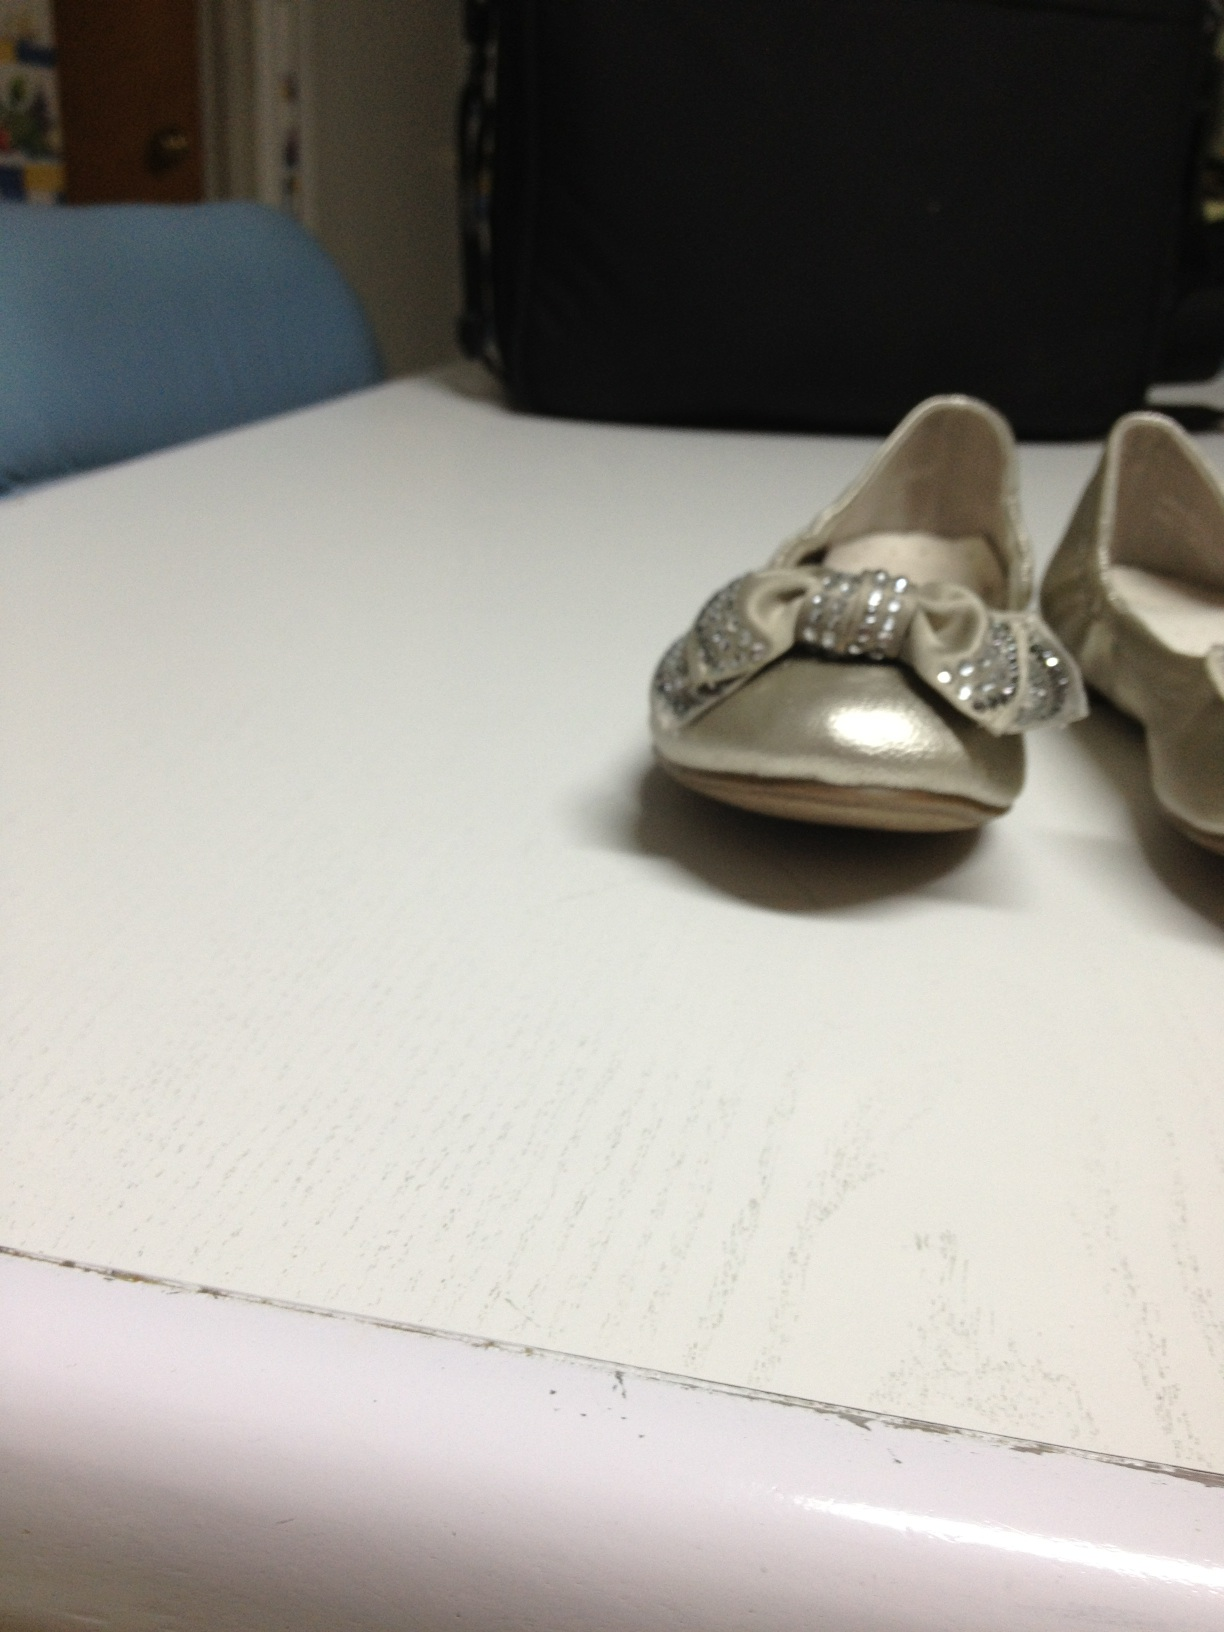What are these? These are a pair of elegant, silver-colored shoes adorned with sparkling bows, likely designed for a child. They give off a formal and festive vibe, making them perfect for special occasions. 